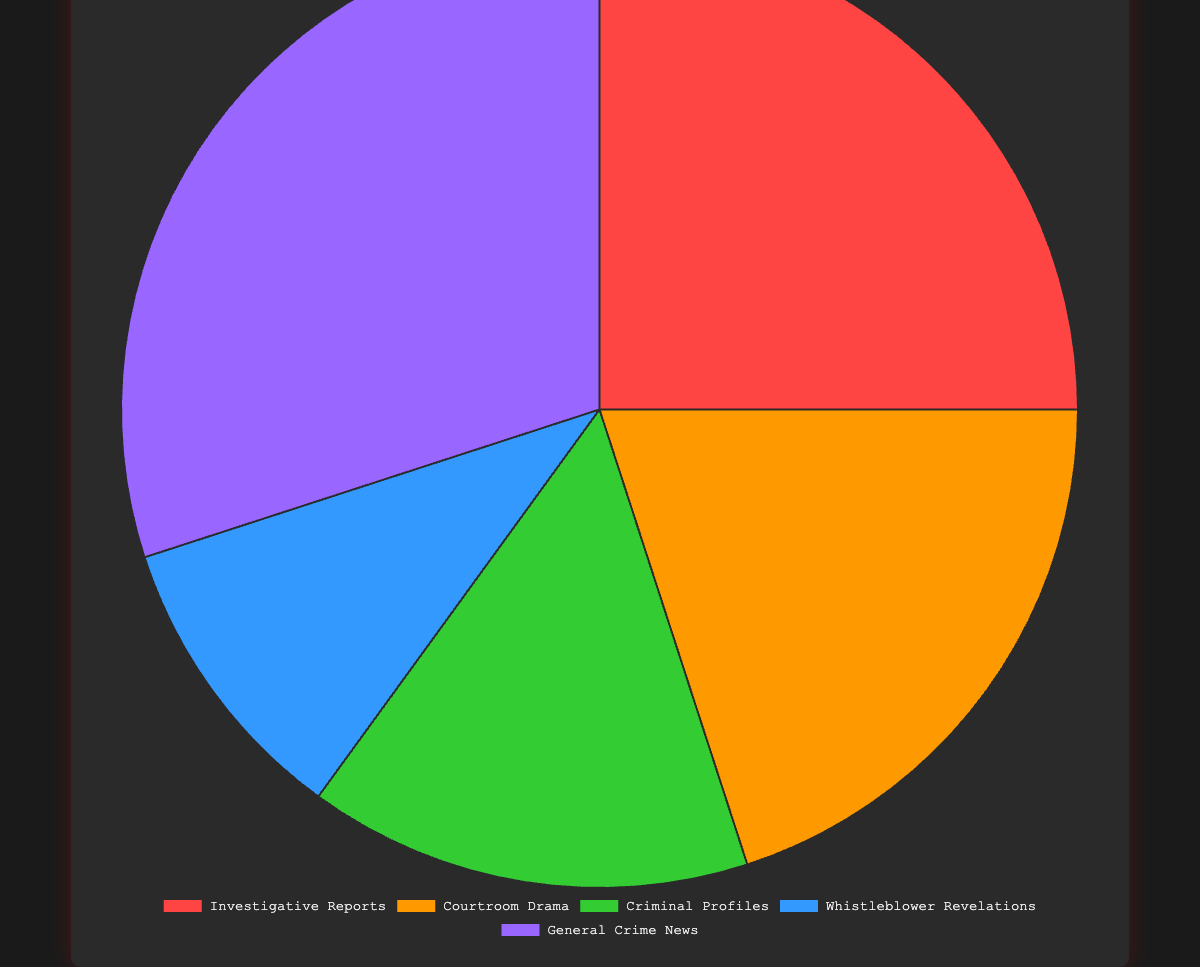Which type of story is covered the most by criminal journalists? Reviewing the pie chart, the largest segment represents "General Crime News," indicating it is the most covered story type by criminal journalists.
Answer: General Crime News What percentage of stories covered by criminal journalists are Criminal Profiles and Whistleblower Revelations combined? Adding the percentages for "Criminal Profiles" (15%) and "Whistleblower Revelations" (10%), we get 15% + 10% = 25%.
Answer: 25% Which story type is covered less than Courtroom Drama but more than Whistleblower Revelations? Comparing the percentages, "Investigative Reports" (25%) has a higher percentage than "Whistleblower Revelations" (10%) but less than "Courtroom Drama" (20%).
Answer: Investigative Reports What is the difference in coverage between the most and least covered story types? The most covered story type is "General Crime News" (30%), and the least covered is "Whistleblower Revelations" (10%). The difference is 30% - 10% = 20%.
Answer: 20% How many story types are covered more than 20% by criminal journalists? The pie chart shows "Investigative Reports" (25%) and "General Crime News" (30%) both have coverage percentages above 20%.
Answer: 2 Which story type is represented by the color red? From the description, the color red corresponds to "Investigative Reports."
Answer: Investigative Reports Is the coverage of Courtroom Drama greater than the combined coverage of Criminal Profiles and Whistleblower Revelations? The coverage of Courtroom Drama is 20%. Combining Criminal Profiles (15%) and Whistleblower Revelations (10%) gives 15% + 10% = 25%, which is greater than 20%.
Answer: No What is the percentage difference between Investigative Reports and Criminal Profiles? Subtracting the coverage percentage of Criminal Profiles (15%) from Investigative Reports (25%) gives 25% - 15% = 10%.
Answer: 10% By how much does General Crime News coverage exceed Whistleblower Revelations coverage? The coverage of General Crime News is 30% and Whistleblower Revelations is 10%. The difference is 30% - 10% = 20%.
Answer: 20% Is the coverage of Investigative Reports more than twice the coverage of Whistleblower Revelations? The coverage of Investigative Reports is 25%, and twice the coverage of Whistleblower Revelations is 10% * 2 = 20%. Since 25% is more than 20%, the answer is yes.
Answer: Yes 